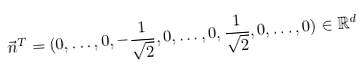Convert formula to latex. <formula><loc_0><loc_0><loc_500><loc_500>\vec { n } ^ { T } = ( 0 , \dots , 0 , - \frac { 1 } { \sqrt { 2 } } , 0 , \dots , 0 , \frac { 1 } { \sqrt { 2 } } , 0 , \dots , 0 ) \in \mathbb { R } ^ { d }</formula> 